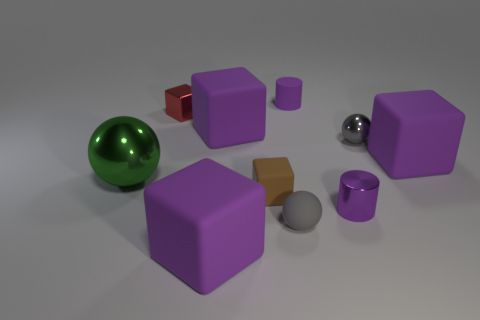What number of balls are there?
Provide a succinct answer. 3. What number of green things are either cubes or rubber cubes?
Ensure brevity in your answer.  0. What number of other objects are there of the same shape as the tiny red metal thing?
Offer a very short reply. 4. Is the color of the ball on the left side of the red shiny object the same as the big rubber block that is right of the tiny purple matte object?
Give a very brief answer. No. What number of small things are red matte things or green metal objects?
Your answer should be compact. 0. There is another metallic object that is the same shape as the large green thing; what is its size?
Offer a terse response. Small. There is a tiny gray object left of the metal ball that is to the right of the small red shiny block; what is its material?
Your answer should be very brief. Rubber. What number of shiny things are tiny blue balls or big balls?
Offer a very short reply. 1. There is a tiny rubber object that is the same shape as the small gray metal thing; what is its color?
Provide a succinct answer. Gray. How many metallic balls are the same color as the small rubber ball?
Offer a terse response. 1. 